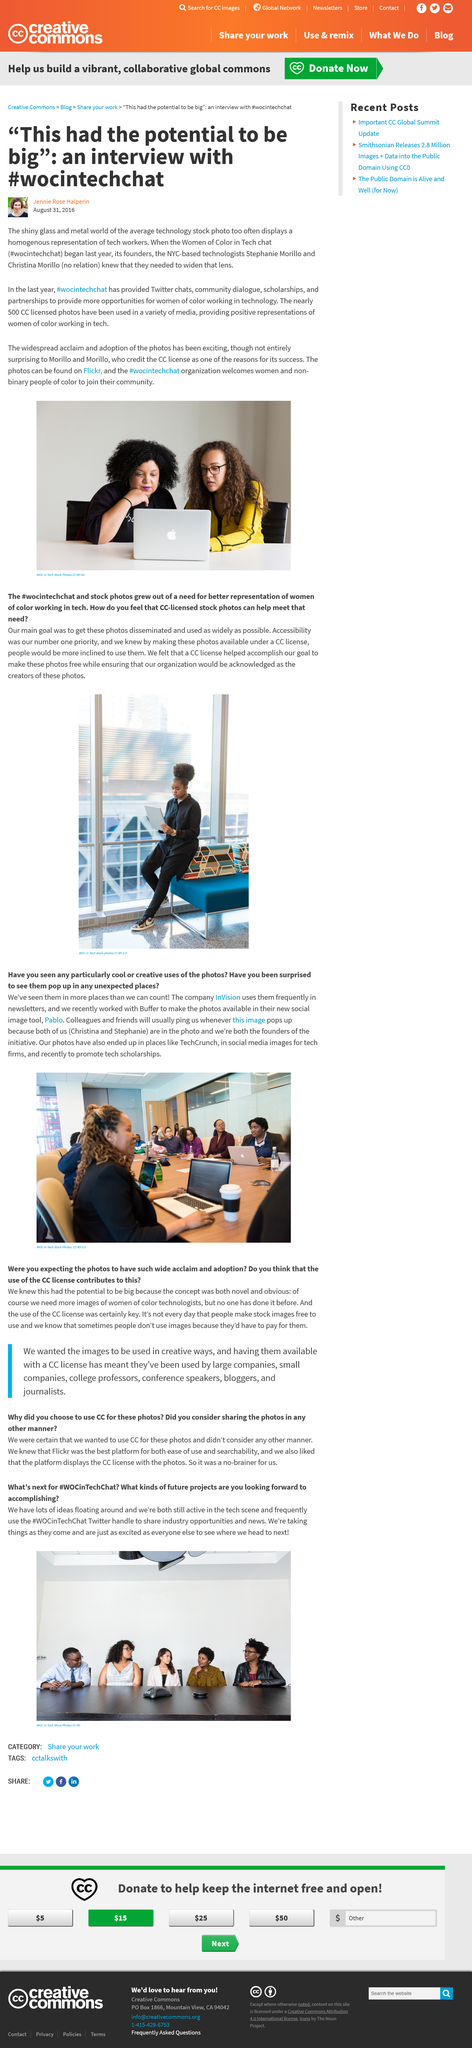Highlight a few significant elements in this photo. The main objective of CC in women of color in tech stock photos was to promote their widespread dissemination. With founders Christina and Stephanie at the helm, the initiative has established a solid foundation for success. The initiative founders are present in the picture. I declared that #wocintechchat stands for Women of Color in Tech chat. The founders of the Women of Color in Tech chat are Stephanie Morillo and Christina Morillo. 